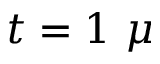<formula> <loc_0><loc_0><loc_500><loc_500>t = 1 \mu</formula> 